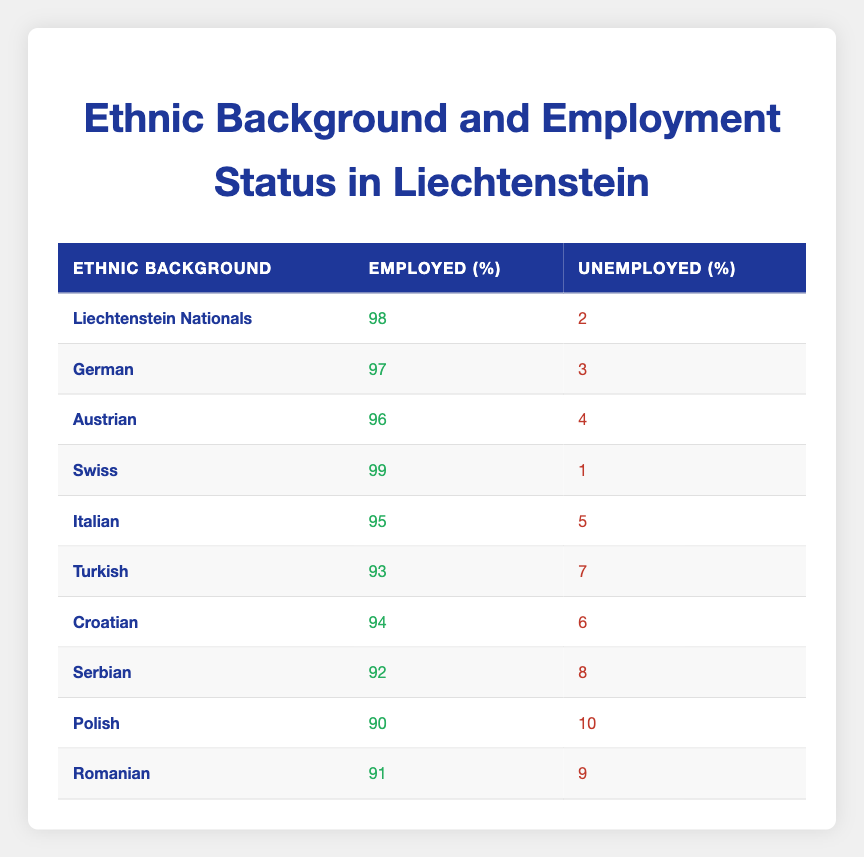What is the employment percentage for Swiss nationals? The table shows that the employment percentage for Swiss nationals is listed under the 'Employed' column. Referring to the row for "Swiss," the value is 99.
Answer: 99 Which ethnic group has the highest unemployment rate? To determine the highest unemployment rate, we need to compare the 'Unemployed' column for all ethnic backgrounds. The highest value is found for the "Polish" group with a rate of 10.
Answer: Polish What is the average employment percentage for all ethnic groups combined? First, sum all employment percentages: 98 + 97 + 96 + 99 + 95 + 93 + 94 + 92 + 90 + 91 =  95.5. Next, divide by the number of groups, which is 10. Therefore, the average employment is 955/10 = 95.5.
Answer: 95.5 Is the unemployment rate for Liechtenstein Nationals lower than that for Italian nationals? Looking at the 'Unemployed' column for both groups, Liechtenstein Nationals have an unemployment rate of 2, while Italians have 5. Since 2 is less than 5, the answer is yes.
Answer: Yes How does the unemployment rate for Turkish nationals compare to that of Serbian nationals? The unemployment rate for Turkish nationals is 7 and for Serbian nationals is 8. Since 7 is less than 8, the Turkish unemployment rate is lower than the Serbian rate.
Answer: Lower What is the difference in employment rates between the Austrian and the Romanian groups? The 'Employed' percentage for Austrians is 96 and for Romanians is 91. The difference is calculated by subtracting the Romanian rate from the Austrian rate: 96 - 91 = 5.
Answer: 5 Is the majority of the employed population from Liechtenstein Nationals or Poles? When comparing 'Employed' rates, Liechtenstein Nationals have 98%, while Polish nationals have only 90%. Since 98% is greater than 90%, the majority is from Liechtenstein Nationals.
Answer: Liechtenstein Nationals What is the total number of unemployed individuals across all ethnic groups? To obtain the total number of unemployed individuals, sum up the 'Unemployed' column: 2 + 3 + 4 + 1 + 5 + 7 + 6 + 8 + 10 + 9 = 55.
Answer: 55 Which ethnic background has a lower unemployment rate: German or Austrian? The unemployment rate for Germans is 3, while for Austrians it is 4. Since 3 is less than 4, Germans have a lower unemployment rate than Austrians.
Answer: German 